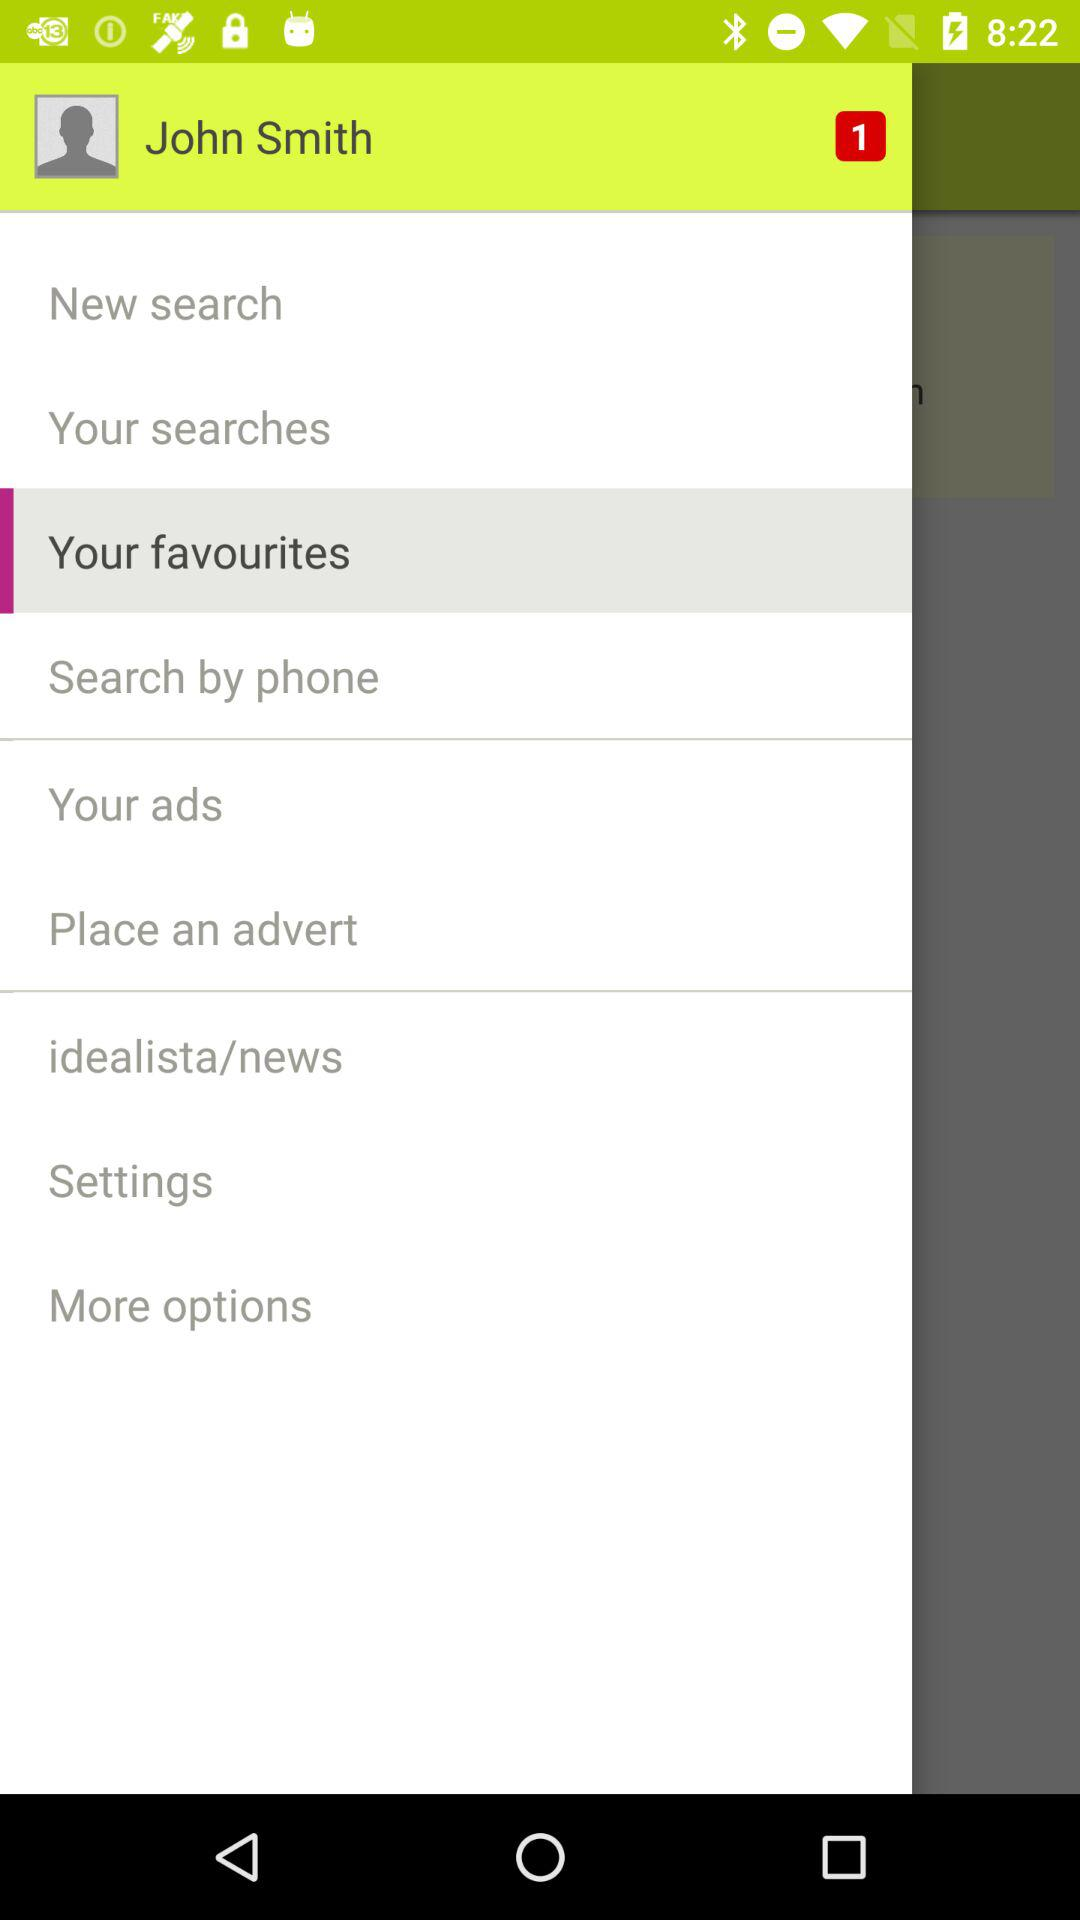What is the selected option? The selected option is "Your favorites". 